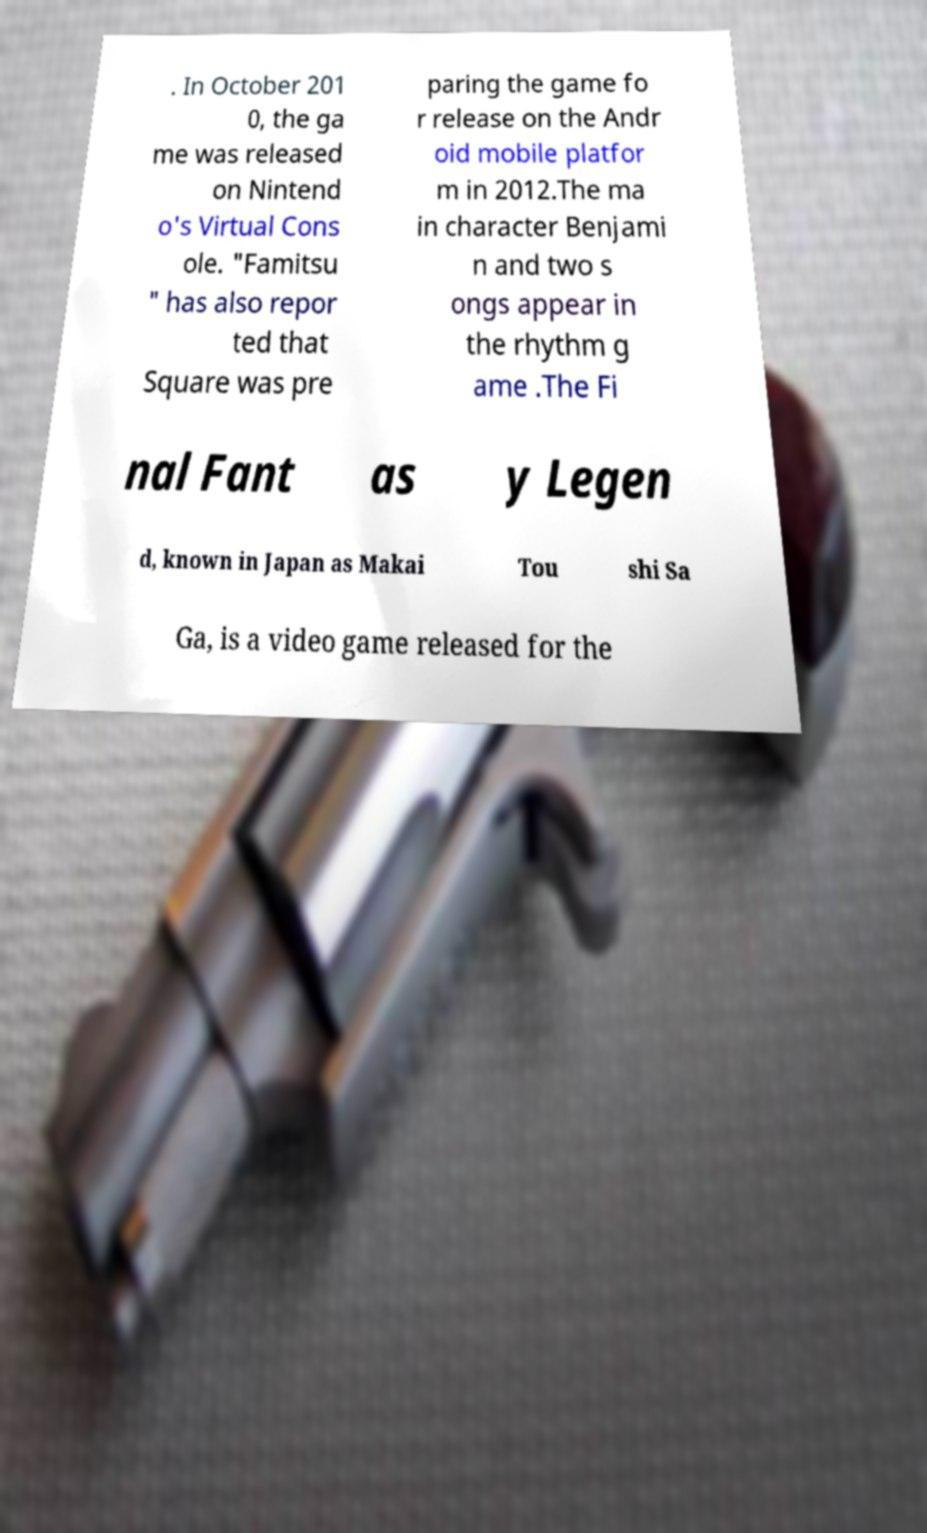I need the written content from this picture converted into text. Can you do that? . In October 201 0, the ga me was released on Nintend o's Virtual Cons ole. "Famitsu " has also repor ted that Square was pre paring the game fo r release on the Andr oid mobile platfor m in 2012.The ma in character Benjami n and two s ongs appear in the rhythm g ame .The Fi nal Fant as y Legen d, known in Japan as Makai Tou shi Sa Ga, is a video game released for the 